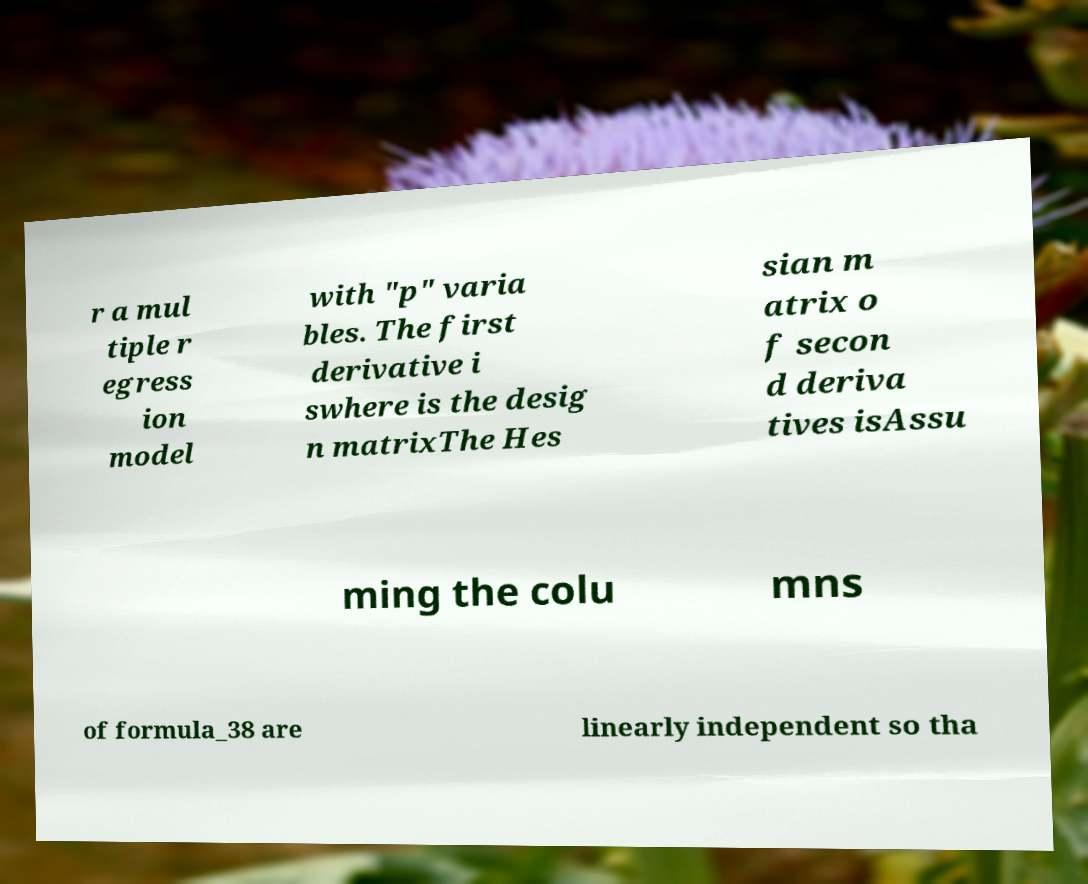Please identify and transcribe the text found in this image. r a mul tiple r egress ion model with "p" varia bles. The first derivative i swhere is the desig n matrixThe Hes sian m atrix o f secon d deriva tives isAssu ming the colu mns of formula_38 are linearly independent so tha 